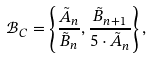<formula> <loc_0><loc_0><loc_500><loc_500>\mathcal { B } _ { C } = \left \{ \frac { \tilde { A } _ { n } } { \tilde { B } _ { n } } , \frac { \tilde { B } _ { n + 1 } } { 5 \cdot \tilde { A } _ { n } } \right \} ,</formula> 